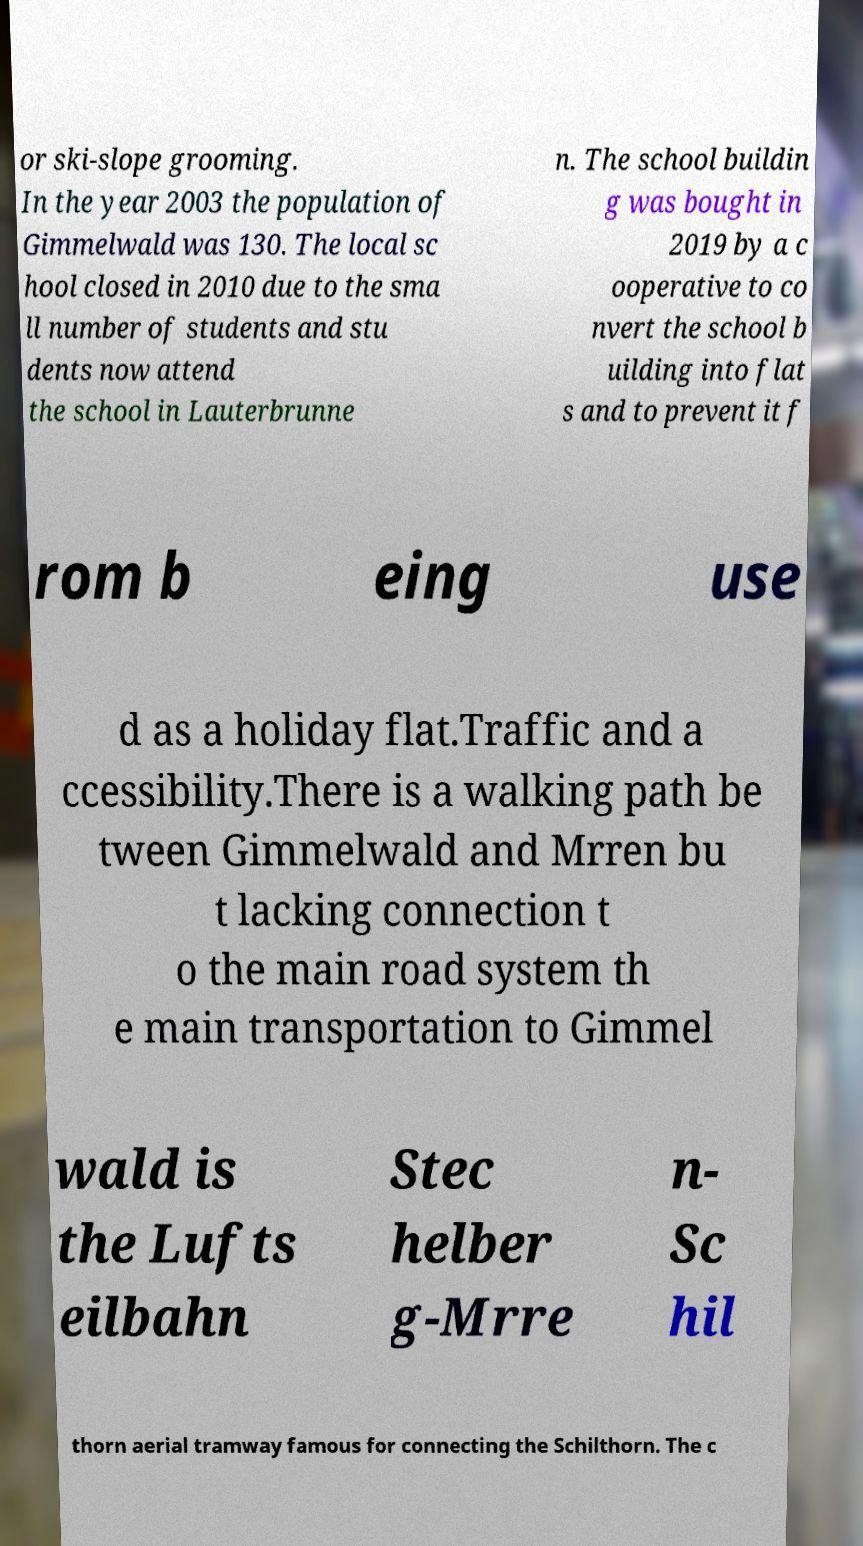There's text embedded in this image that I need extracted. Can you transcribe it verbatim? or ski-slope grooming. In the year 2003 the population of Gimmelwald was 130. The local sc hool closed in 2010 due to the sma ll number of students and stu dents now attend the school in Lauterbrunne n. The school buildin g was bought in 2019 by a c ooperative to co nvert the school b uilding into flat s and to prevent it f rom b eing use d as a holiday flat.Traffic and a ccessibility.There is a walking path be tween Gimmelwald and Mrren bu t lacking connection t o the main road system th e main transportation to Gimmel wald is the Lufts eilbahn Stec helber g-Mrre n- Sc hil thorn aerial tramway famous for connecting the Schilthorn. The c 